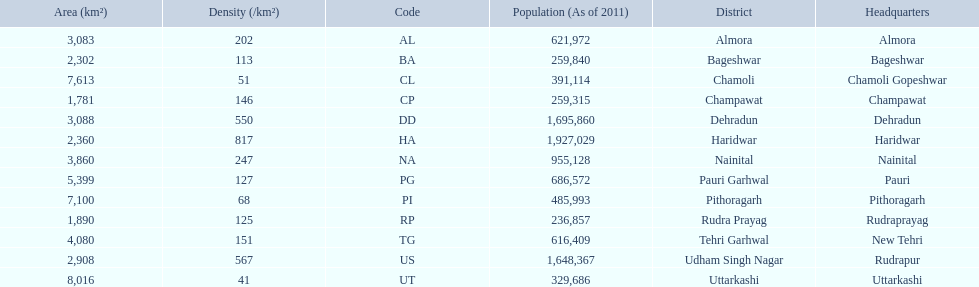What are all the districts? Almora, Bageshwar, Chamoli, Champawat, Dehradun, Haridwar, Nainital, Pauri Garhwal, Pithoragarh, Rudra Prayag, Tehri Garhwal, Udham Singh Nagar, Uttarkashi. Could you help me parse every detail presented in this table? {'header': ['Area (km²)', 'Density (/km²)', 'Code', 'Population (As of 2011)', 'District', 'Headquarters'], 'rows': [['3,083', '202', 'AL', '621,972', 'Almora', 'Almora'], ['2,302', '113', 'BA', '259,840', 'Bageshwar', 'Bageshwar'], ['7,613', '51', 'CL', '391,114', 'Chamoli', 'Chamoli Gopeshwar'], ['1,781', '146', 'CP', '259,315', 'Champawat', 'Champawat'], ['3,088', '550', 'DD', '1,695,860', 'Dehradun', 'Dehradun'], ['2,360', '817', 'HA', '1,927,029', 'Haridwar', 'Haridwar'], ['3,860', '247', 'NA', '955,128', 'Nainital', 'Nainital'], ['5,399', '127', 'PG', '686,572', 'Pauri Garhwal', 'Pauri'], ['7,100', '68', 'PI', '485,993', 'Pithoragarh', 'Pithoragarh'], ['1,890', '125', 'RP', '236,857', 'Rudra Prayag', 'Rudraprayag'], ['4,080', '151', 'TG', '616,409', 'Tehri Garhwal', 'New Tehri'], ['2,908', '567', 'US', '1,648,367', 'Udham Singh Nagar', 'Rudrapur'], ['8,016', '41', 'UT', '329,686', 'Uttarkashi', 'Uttarkashi']]} And their densities? 202, 113, 51, 146, 550, 817, 247, 127, 68, 125, 151, 567, 41. Now, which district's density is 51? Chamoli. 